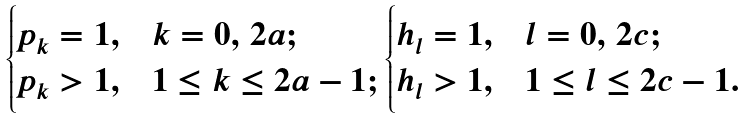Convert formula to latex. <formula><loc_0><loc_0><loc_500><loc_500>\begin{cases} p _ { k } = 1 , & k = 0 , \, 2 a ; \\ p _ { k } > 1 , & 1 \leq k \leq 2 a - 1 ; \\ \end{cases} \, \begin{cases} h _ { l } = 1 , & l = 0 , \, 2 c ; \\ h _ { l } > 1 , & 1 \leq l \leq 2 c - 1 . \\ \end{cases}</formula> 